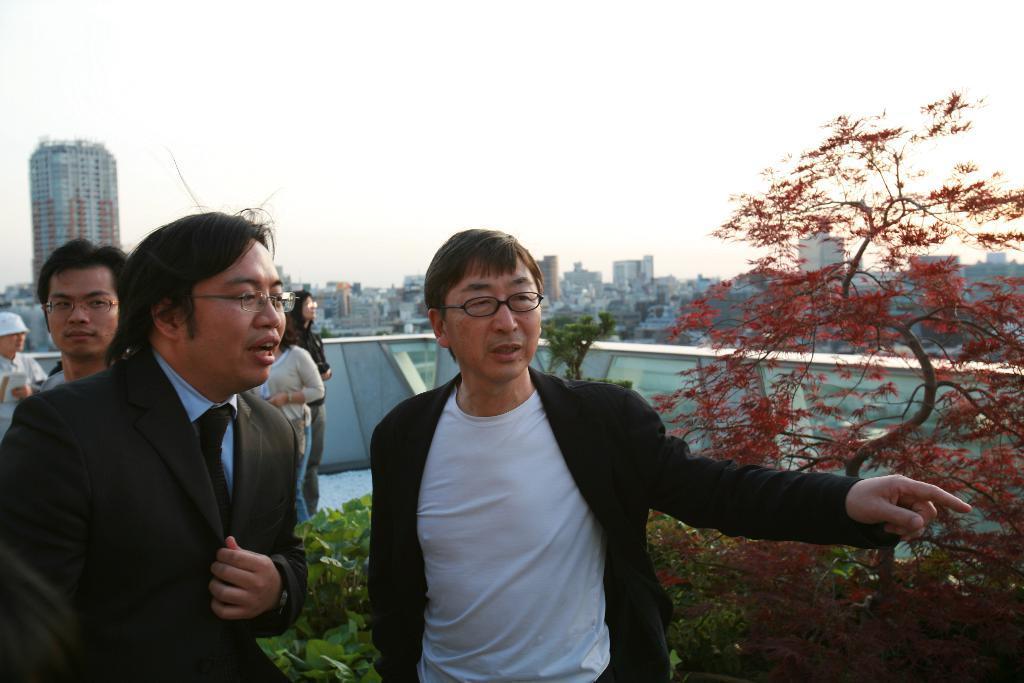Could you give a brief overview of what you see in this image? In this image there are a few people standing. In the foreground there are two men. They are talking. Behind them there are plants. Behind the plants there is a railing. In the background there are buildings and skyscrapers. At the top there is the sky. 